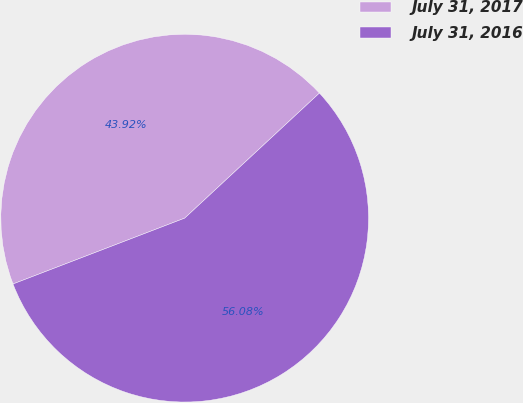Convert chart to OTSL. <chart><loc_0><loc_0><loc_500><loc_500><pie_chart><fcel>July 31, 2017<fcel>July 31, 2016<nl><fcel>43.92%<fcel>56.08%<nl></chart> 